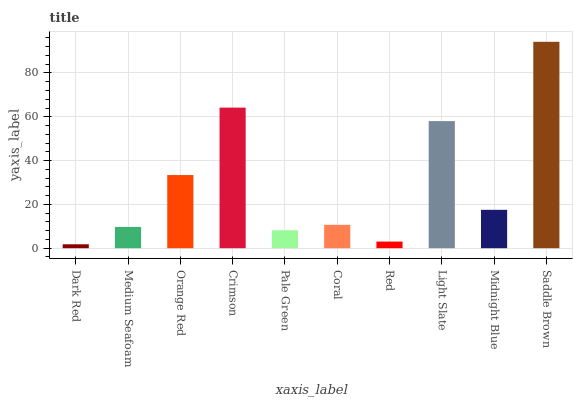Is Dark Red the minimum?
Answer yes or no. Yes. Is Saddle Brown the maximum?
Answer yes or no. Yes. Is Medium Seafoam the minimum?
Answer yes or no. No. Is Medium Seafoam the maximum?
Answer yes or no. No. Is Medium Seafoam greater than Dark Red?
Answer yes or no. Yes. Is Dark Red less than Medium Seafoam?
Answer yes or no. Yes. Is Dark Red greater than Medium Seafoam?
Answer yes or no. No. Is Medium Seafoam less than Dark Red?
Answer yes or no. No. Is Midnight Blue the high median?
Answer yes or no. Yes. Is Coral the low median?
Answer yes or no. Yes. Is Saddle Brown the high median?
Answer yes or no. No. Is Saddle Brown the low median?
Answer yes or no. No. 